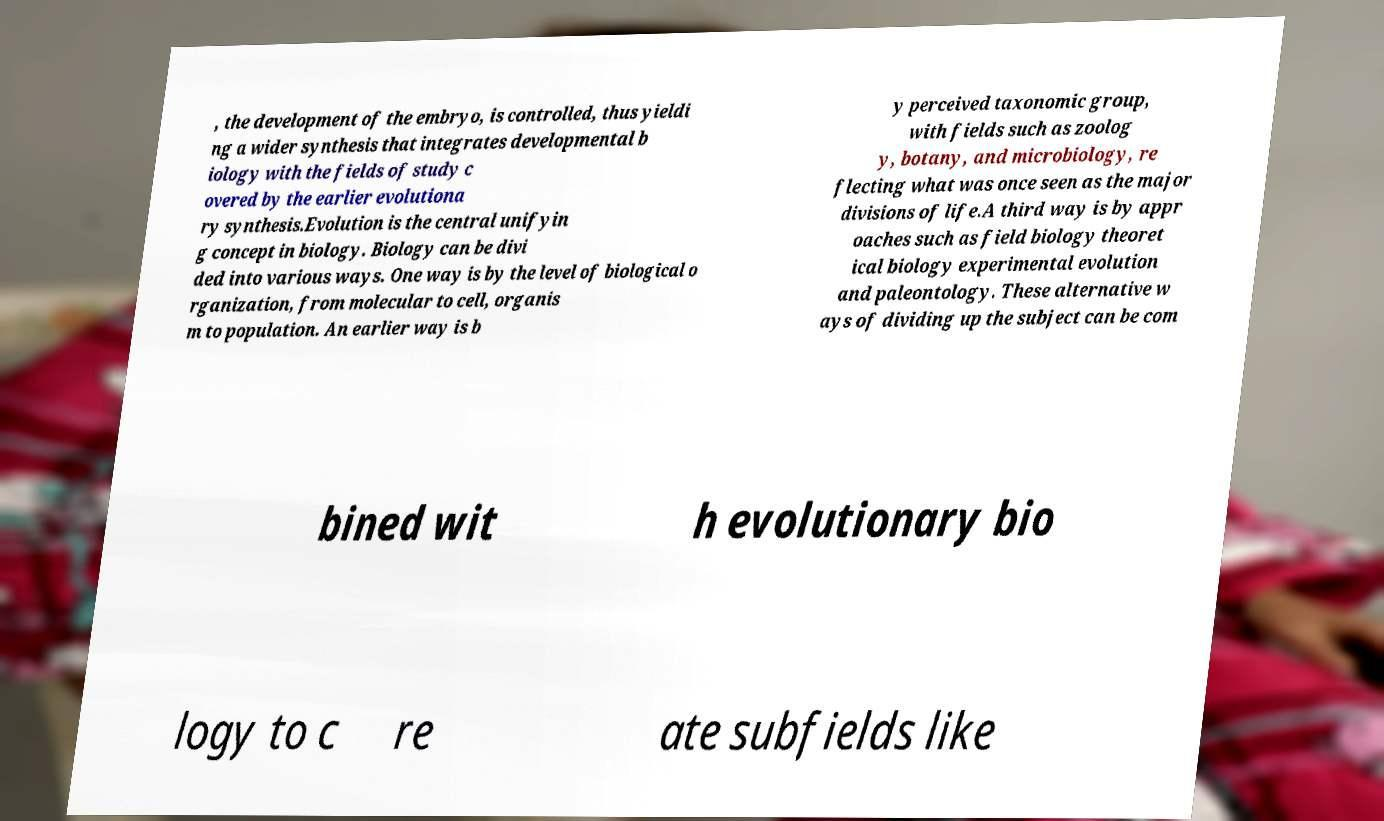What messages or text are displayed in this image? I need them in a readable, typed format. , the development of the embryo, is controlled, thus yieldi ng a wider synthesis that integrates developmental b iology with the fields of study c overed by the earlier evolutiona ry synthesis.Evolution is the central unifyin g concept in biology. Biology can be divi ded into various ways. One way is by the level of biological o rganization, from molecular to cell, organis m to population. An earlier way is b y perceived taxonomic group, with fields such as zoolog y, botany, and microbiology, re flecting what was once seen as the major divisions of life.A third way is by appr oaches such as field biology theoret ical biology experimental evolution and paleontology. These alternative w ays of dividing up the subject can be com bined wit h evolutionary bio logy to c re ate subfields like 